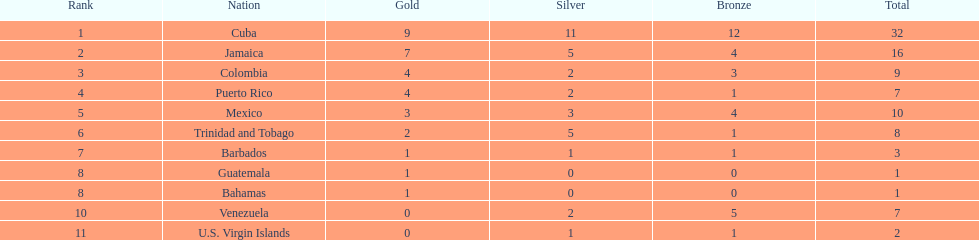Nations that had 10 or more medals each Cuba, Jamaica, Mexico. 